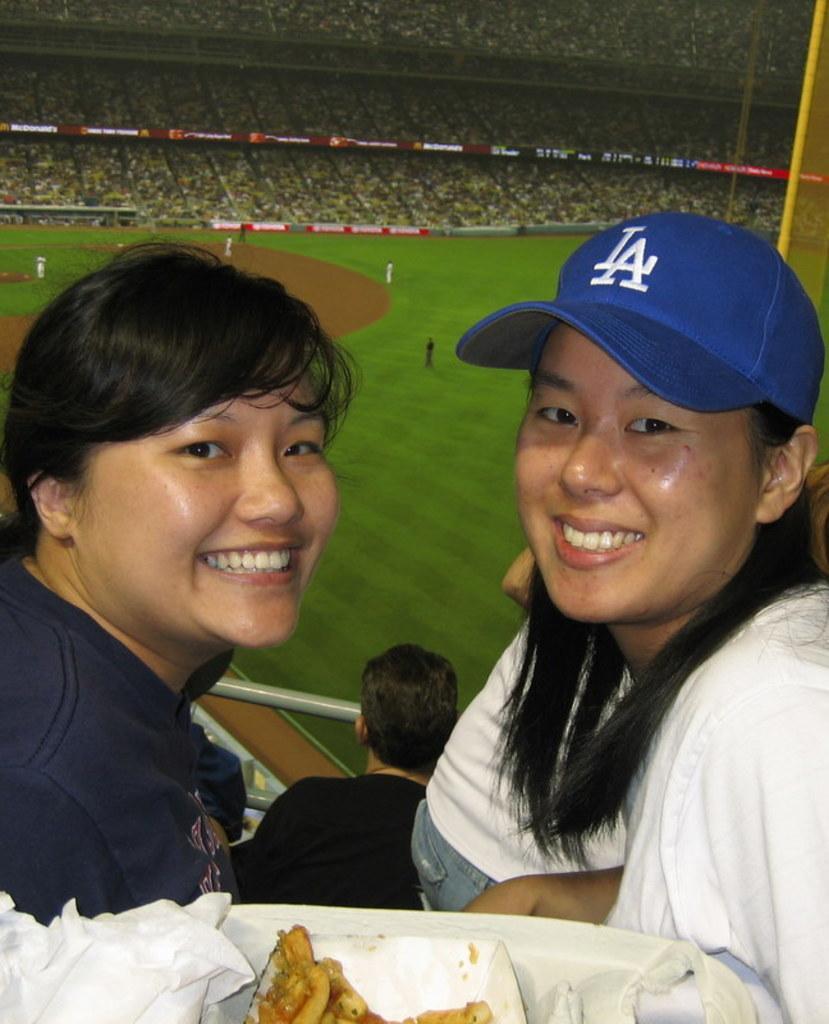Could you give a brief overview of what you see in this image? In this picture there are two girls sitting in the front, smiling and giving a pose to the camera. Behind there is a cricket stadium and many audience are sitting on the chairs. 